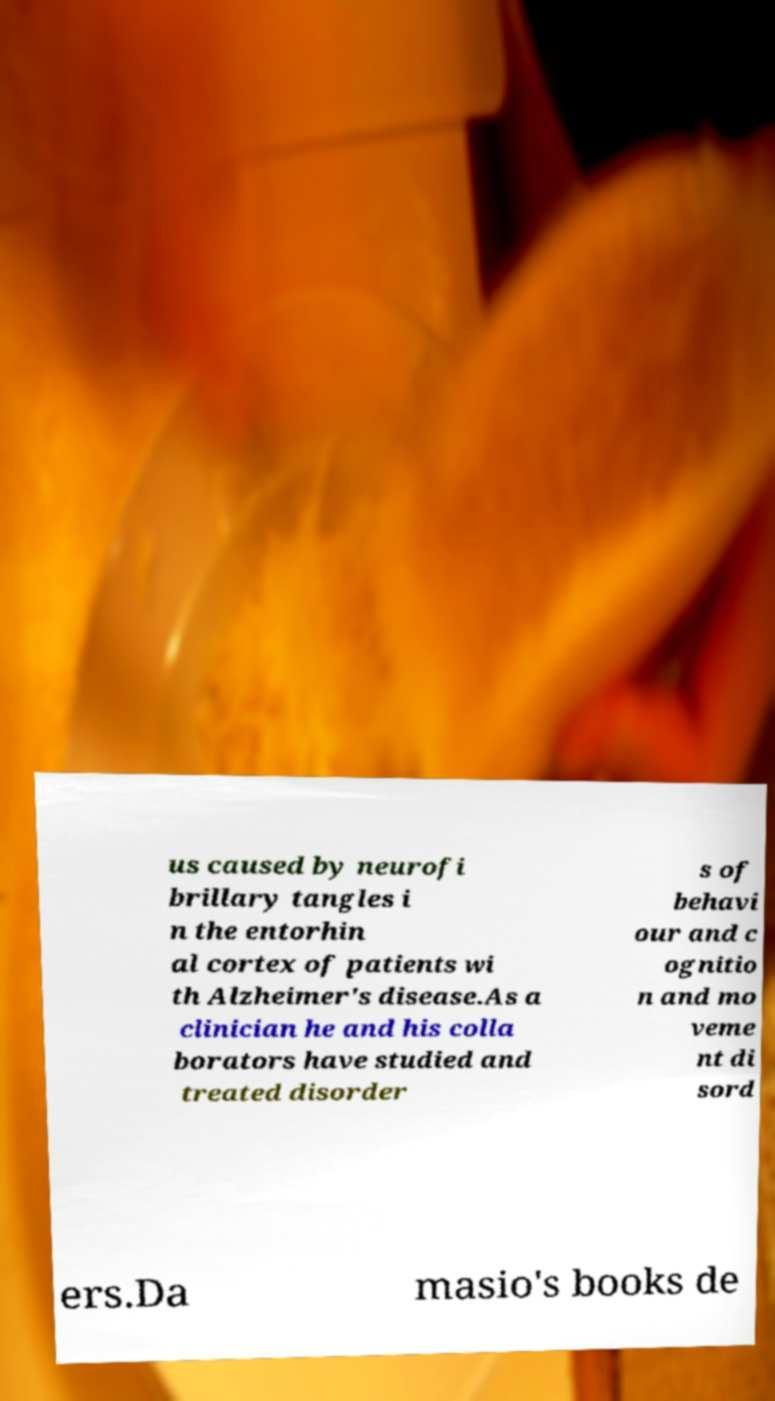Please read and relay the text visible in this image. What does it say? us caused by neurofi brillary tangles i n the entorhin al cortex of patients wi th Alzheimer's disease.As a clinician he and his colla borators have studied and treated disorder s of behavi our and c ognitio n and mo veme nt di sord ers.Da masio's books de 